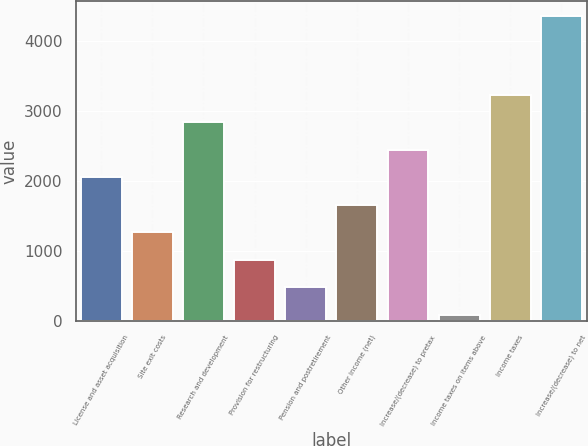<chart> <loc_0><loc_0><loc_500><loc_500><bar_chart><fcel>License and asset acquisition<fcel>Site exit costs<fcel>Research and development<fcel>Provision for restructuring<fcel>Pension and postretirement<fcel>Other income (net)<fcel>Increase/(decrease) to pretax<fcel>Income taxes on items above<fcel>Income taxes<fcel>Increase/(decrease) to net<nl><fcel>2054.5<fcel>1267.5<fcel>2841.5<fcel>874<fcel>480.5<fcel>1661<fcel>2448<fcel>87<fcel>3235<fcel>4356.5<nl></chart> 